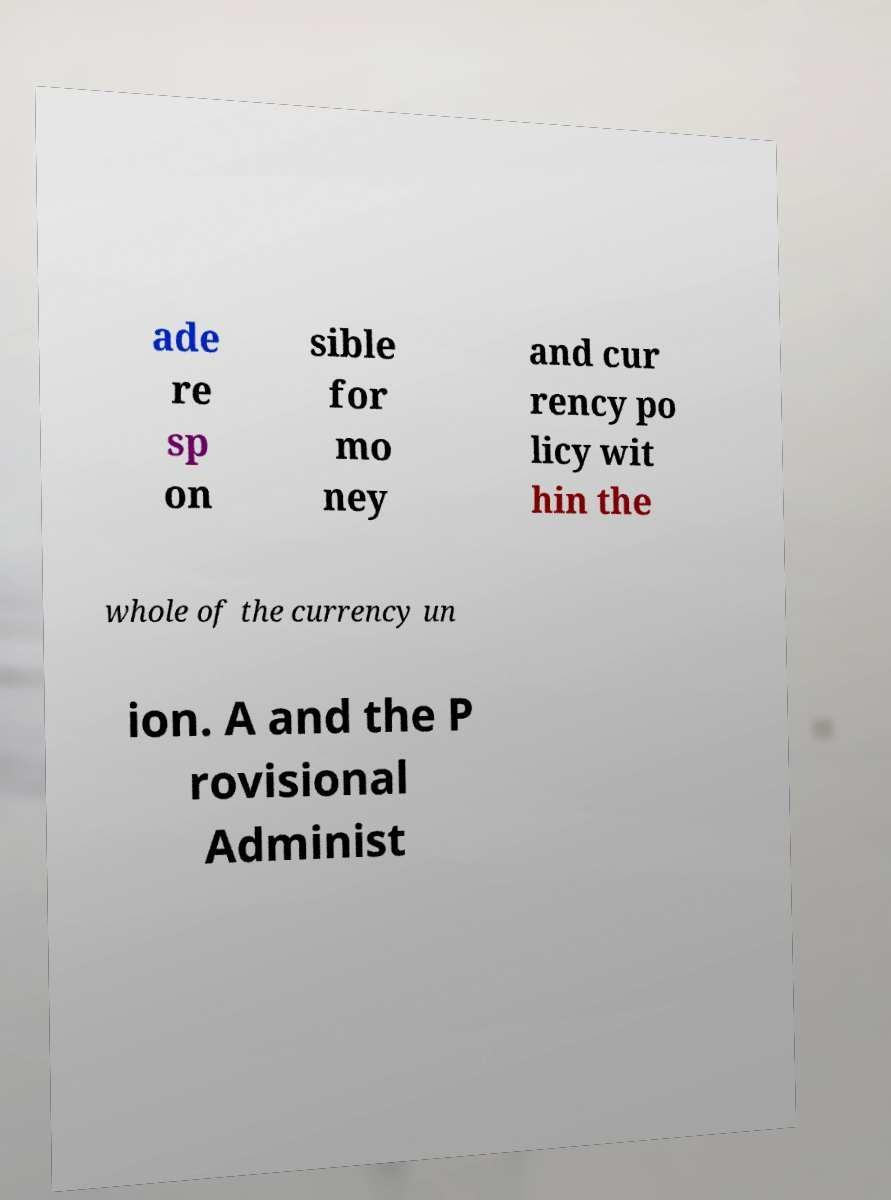I need the written content from this picture converted into text. Can you do that? ade re sp on sible for mo ney and cur rency po licy wit hin the whole of the currency un ion. A and the P rovisional Administ 